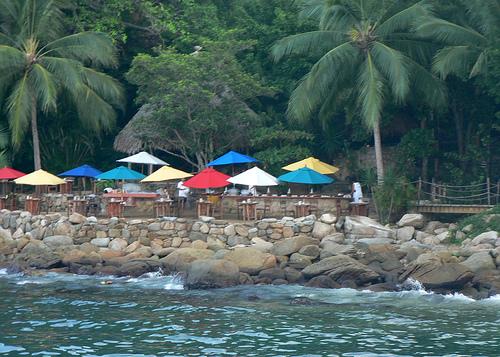Is there a bridge in this picture?
Answer briefly. Yes. How many yellow umbrellas are there?
Be succinct. 3. How many different colors of umbrella are there?
Write a very short answer. 5. 